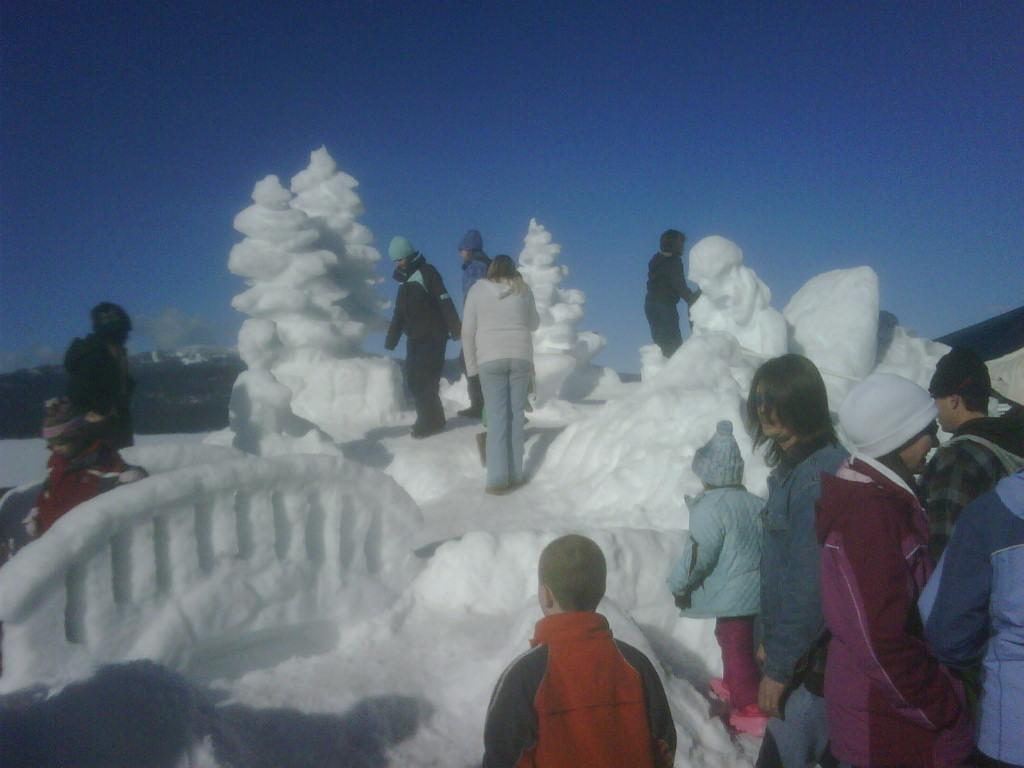How would you summarize this image in a sentence or two? In the image there are few people and in front of them there is some architecture made up of ice and around some sculptures there are few people. 